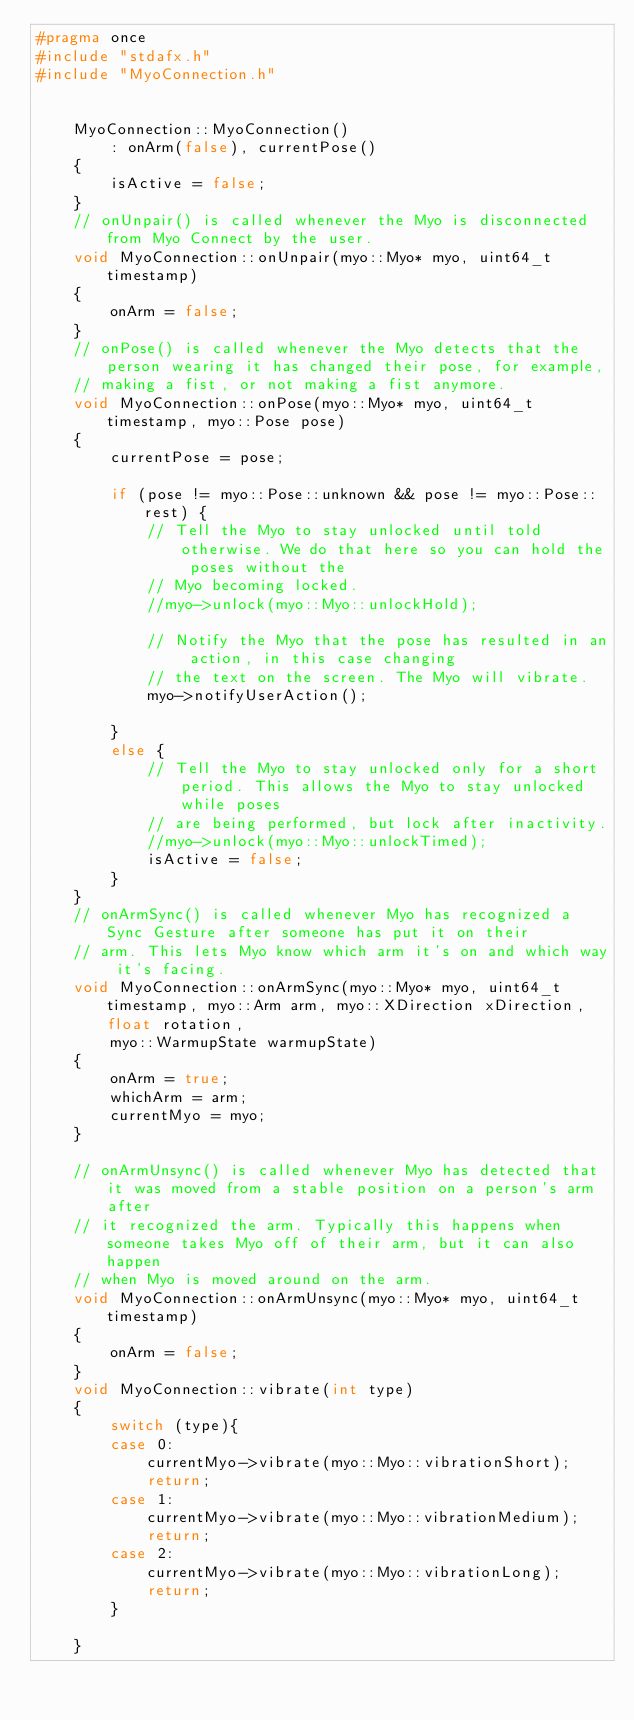Convert code to text. <code><loc_0><loc_0><loc_500><loc_500><_C++_>#pragma once
#include "stdafx.h"
#include "MyoConnection.h"


	MyoConnection::MyoConnection()
		: onArm(false), currentPose()
	{
		isActive = false;
	}
	// onUnpair() is called whenever the Myo is disconnected from Myo Connect by the user.
	void MyoConnection::onUnpair(myo::Myo* myo, uint64_t timestamp)
	{
		onArm = false;
	}
	// onPose() is called whenever the Myo detects that the person wearing it has changed their pose, for example,
	// making a fist, or not making a fist anymore.
	void MyoConnection::onPose(myo::Myo* myo, uint64_t timestamp, myo::Pose pose)
	{
		currentPose = pose;

		if (pose != myo::Pose::unknown && pose != myo::Pose::rest) {
			// Tell the Myo to stay unlocked until told otherwise. We do that here so you can hold the poses without the
			// Myo becoming locked.
			//myo->unlock(myo::Myo::unlockHold);

			// Notify the Myo that the pose has resulted in an action, in this case changing
			// the text on the screen. The Myo will vibrate.
			myo->notifyUserAction();
			
		}
		else {
			// Tell the Myo to stay unlocked only for a short period. This allows the Myo to stay unlocked while poses
			// are being performed, but lock after inactivity.
			//myo->unlock(myo::Myo::unlockTimed);
			isActive = false;
		}
	}
	// onArmSync() is called whenever Myo has recognized a Sync Gesture after someone has put it on their
	// arm. This lets Myo know which arm it's on and which way it's facing.
	void MyoConnection::onArmSync(myo::Myo* myo, uint64_t timestamp, myo::Arm arm, myo::XDirection xDirection, float rotation,
		myo::WarmupState warmupState)
	{
		onArm = true;
		whichArm = arm;
		currentMyo = myo;
	}

	// onArmUnsync() is called whenever Myo has detected that it was moved from a stable position on a person's arm after
	// it recognized the arm. Typically this happens when someone takes Myo off of their arm, but it can also happen
	// when Myo is moved around on the arm.
	void MyoConnection::onArmUnsync(myo::Myo* myo, uint64_t timestamp)
	{
		onArm = false;
	}
	void MyoConnection::vibrate(int type)
	{
		switch (type){
		case 0:
			currentMyo->vibrate(myo::Myo::vibrationShort);
			return;
		case 1:
			currentMyo->vibrate(myo::Myo::vibrationMedium);
			return;
		case 2:
			currentMyo->vibrate(myo::Myo::vibrationLong);
			return;
		}
		
	}

	

</code> 